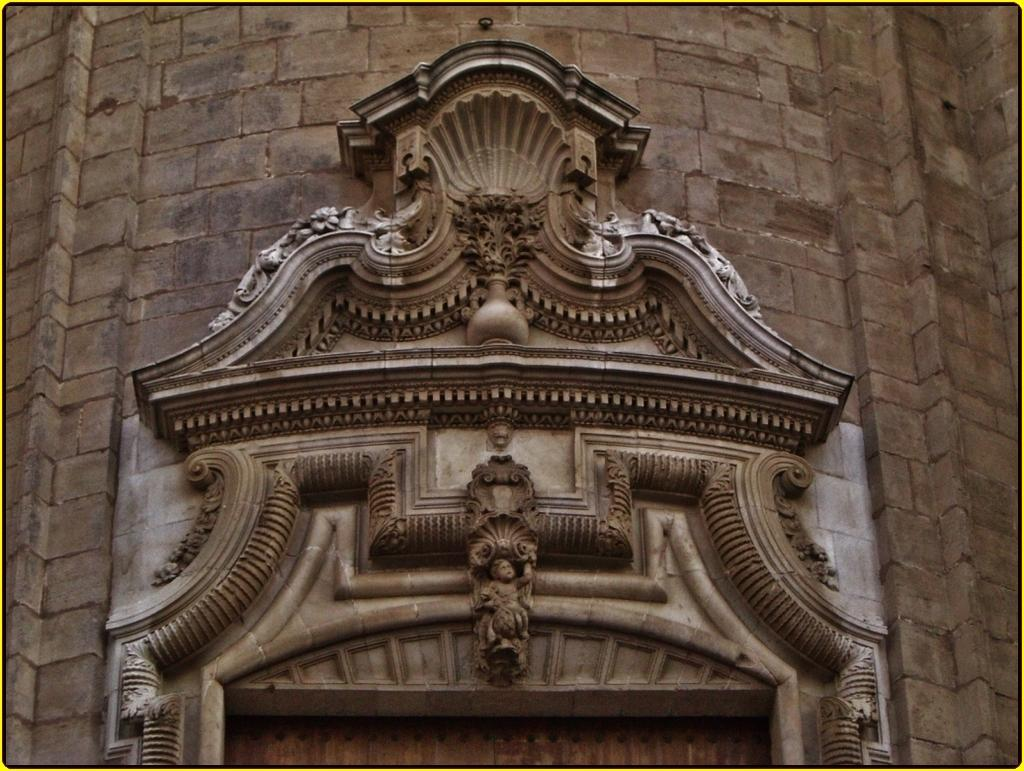What is present on the wall in the image? There is an arch on the wall in the image. What is featured on the arch? There is some craft on the arch. What is the cause of the self-swimming abilities of the craft on the arch? There is no indication in the image that the craft has self-swimming abilities, nor is there any mention of a cause for such abilities. 